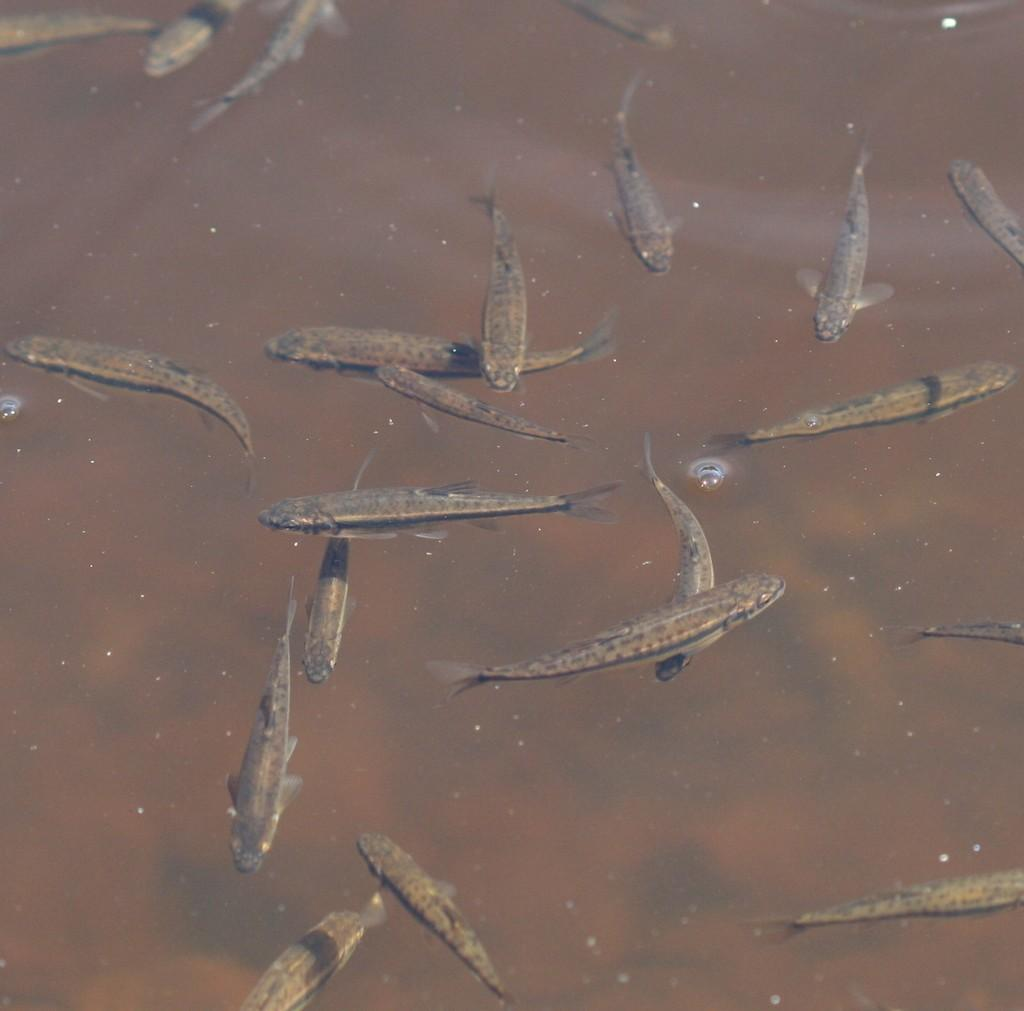What type of animals can be seen in the image? There are fishes in the image. Where are the fishes located? The fishes are in the water. What time does the sheet of paper indicate in the image? There is no sheet of paper present in the image; it features fishes in the water. How many bubbles can be seen around the fishes in the image? There are no bubbles visible around the fishes in the image. 